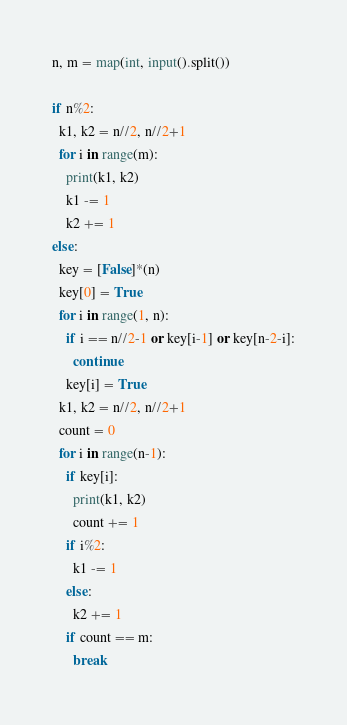<code> <loc_0><loc_0><loc_500><loc_500><_Python_>n, m = map(int, input().split())

if n%2:
  k1, k2 = n//2, n//2+1
  for i in range(m):
    print(k1, k2)
    k1 -= 1
    k2 += 1
else:
  key = [False]*(n)
  key[0] = True
  for i in range(1, n):
    if i == n//2-1 or key[i-1] or key[n-2-i]:
      continue
    key[i] = True
  k1, k2 = n//2, n//2+1
  count = 0
  for i in range(n-1):
    if key[i]:
      print(k1, k2)
      count += 1
    if i%2:
      k1 -= 1
    else:
      k2 += 1
    if count == m:
      break</code> 